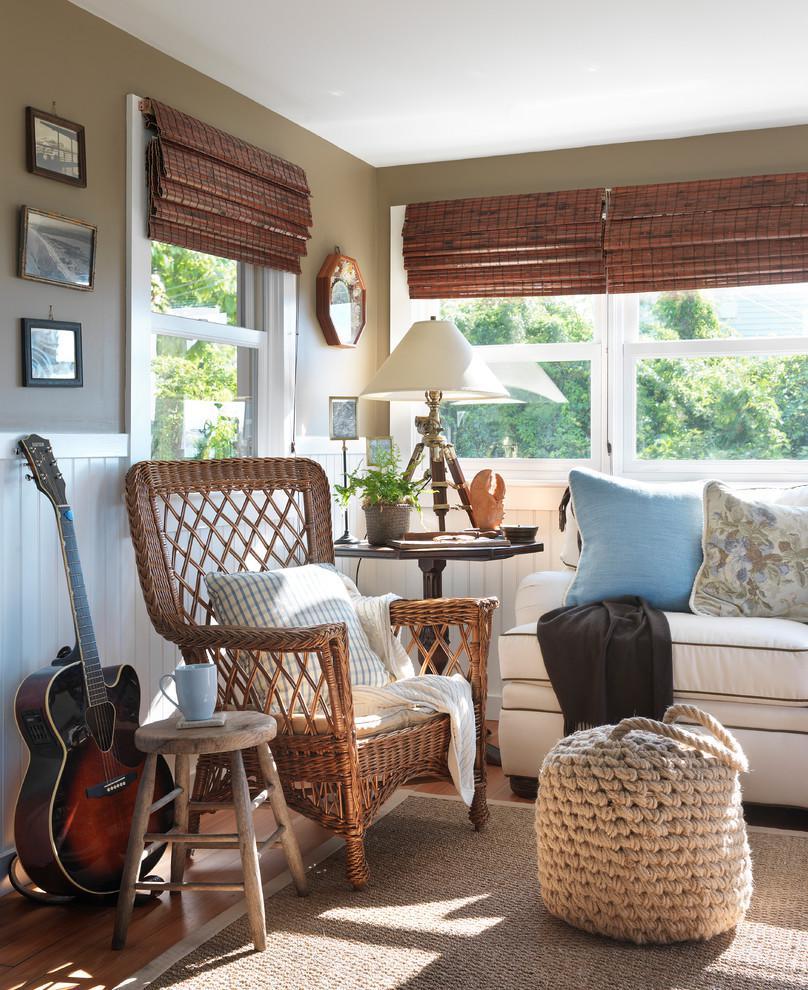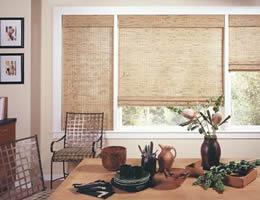The first image is the image on the left, the second image is the image on the right. Evaluate the accuracy of this statement regarding the images: "There are six blinds.". Is it true? Answer yes or no. Yes. The first image is the image on the left, the second image is the image on the right. Considering the images on both sides, is "At least one shade is all the way closed." valid? Answer yes or no. Yes. 